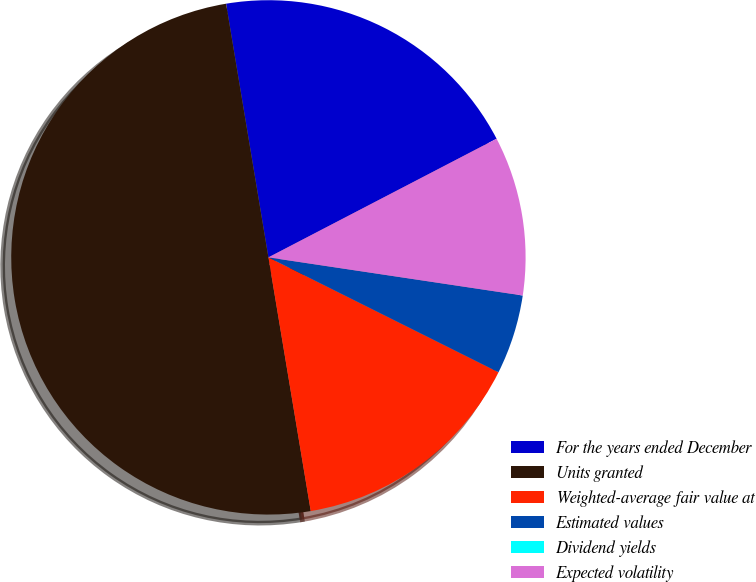<chart> <loc_0><loc_0><loc_500><loc_500><pie_chart><fcel>For the years ended December<fcel>Units granted<fcel>Weighted-average fair value at<fcel>Estimated values<fcel>Dividend yields<fcel>Expected volatility<nl><fcel>20.0%<fcel>50.0%<fcel>15.0%<fcel>5.0%<fcel>0.0%<fcel>10.0%<nl></chart> 